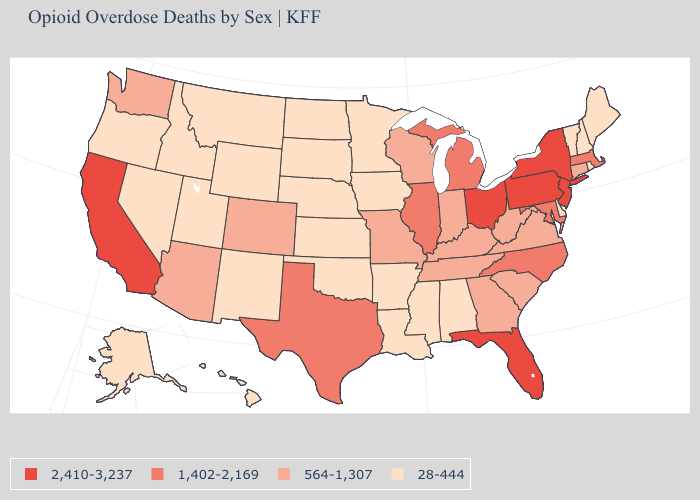Which states have the lowest value in the MidWest?
Write a very short answer. Iowa, Kansas, Minnesota, Nebraska, North Dakota, South Dakota. Which states have the lowest value in the South?
Concise answer only. Alabama, Arkansas, Delaware, Louisiana, Mississippi, Oklahoma. What is the value of Rhode Island?
Quick response, please. 28-444. How many symbols are there in the legend?
Give a very brief answer. 4. Name the states that have a value in the range 2,410-3,237?
Answer briefly. California, Florida, New Jersey, New York, Ohio, Pennsylvania. Does Minnesota have a lower value than Georgia?
Quick response, please. Yes. Name the states that have a value in the range 564-1,307?
Concise answer only. Arizona, Colorado, Connecticut, Georgia, Indiana, Kentucky, Missouri, South Carolina, Tennessee, Virginia, Washington, West Virginia, Wisconsin. Name the states that have a value in the range 564-1,307?
Write a very short answer. Arizona, Colorado, Connecticut, Georgia, Indiana, Kentucky, Missouri, South Carolina, Tennessee, Virginia, Washington, West Virginia, Wisconsin. Which states have the highest value in the USA?
Give a very brief answer. California, Florida, New Jersey, New York, Ohio, Pennsylvania. Does the map have missing data?
Be succinct. No. What is the value of Louisiana?
Write a very short answer. 28-444. Does the first symbol in the legend represent the smallest category?
Answer briefly. No. What is the highest value in the MidWest ?
Answer briefly. 2,410-3,237. What is the value of Kentucky?
Quick response, please. 564-1,307. Does Nevada have the lowest value in the USA?
Concise answer only. Yes. 